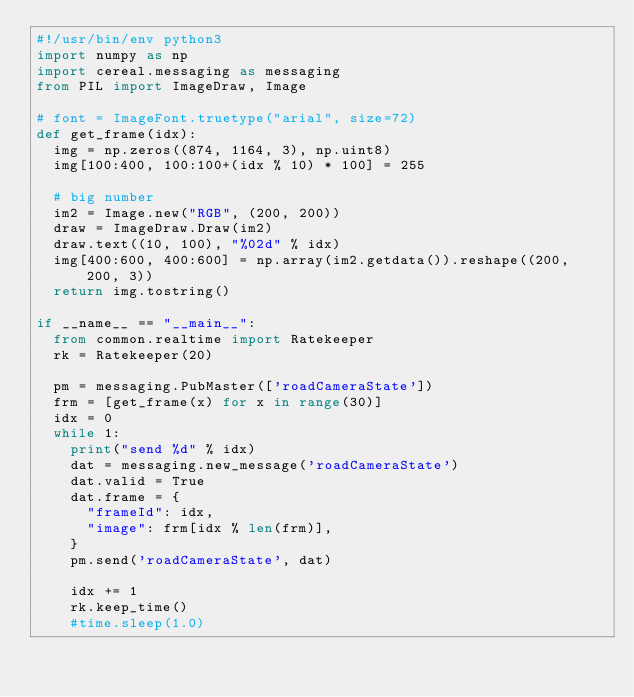Convert code to text. <code><loc_0><loc_0><loc_500><loc_500><_Python_>#!/usr/bin/env python3
import numpy as np
import cereal.messaging as messaging
from PIL import ImageDraw, Image

# font = ImageFont.truetype("arial", size=72)
def get_frame(idx):
  img = np.zeros((874, 1164, 3), np.uint8)
  img[100:400, 100:100+(idx % 10) * 100] = 255

  # big number
  im2 = Image.new("RGB", (200, 200))
  draw = ImageDraw.Draw(im2)
  draw.text((10, 100), "%02d" % idx)
  img[400:600, 400:600] = np.array(im2.getdata()).reshape((200, 200, 3))
  return img.tostring()

if __name__ == "__main__":
  from common.realtime import Ratekeeper
  rk = Ratekeeper(20)

  pm = messaging.PubMaster(['roadCameraState'])
  frm = [get_frame(x) for x in range(30)]
  idx = 0
  while 1:
    print("send %d" % idx)
    dat = messaging.new_message('roadCameraState')
    dat.valid = True
    dat.frame = {
      "frameId": idx,
      "image": frm[idx % len(frm)],
    }
    pm.send('roadCameraState', dat)

    idx += 1
    rk.keep_time()
    #time.sleep(1.0)
</code> 